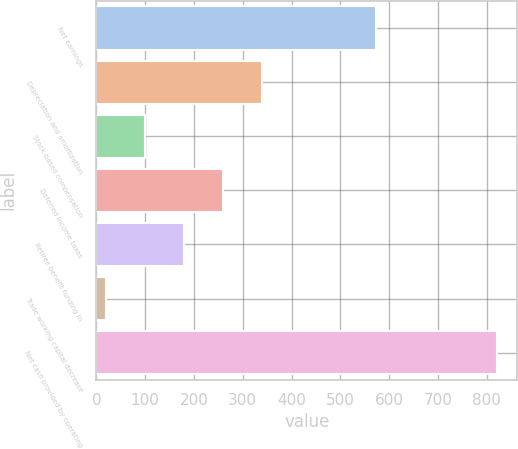Convert chart to OTSL. <chart><loc_0><loc_0><loc_500><loc_500><bar_chart><fcel>Net earnings<fcel>Depreciation and amortization<fcel>Stock-based compensation<fcel>Deferred income taxes<fcel>Retiree benefit funding in<fcel>Trade working capital decrease<fcel>Net cash provided by operating<nl><fcel>573<fcel>340.2<fcel>99.3<fcel>259.9<fcel>179.6<fcel>19<fcel>822<nl></chart> 